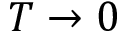<formula> <loc_0><loc_0><loc_500><loc_500>T \to 0</formula> 